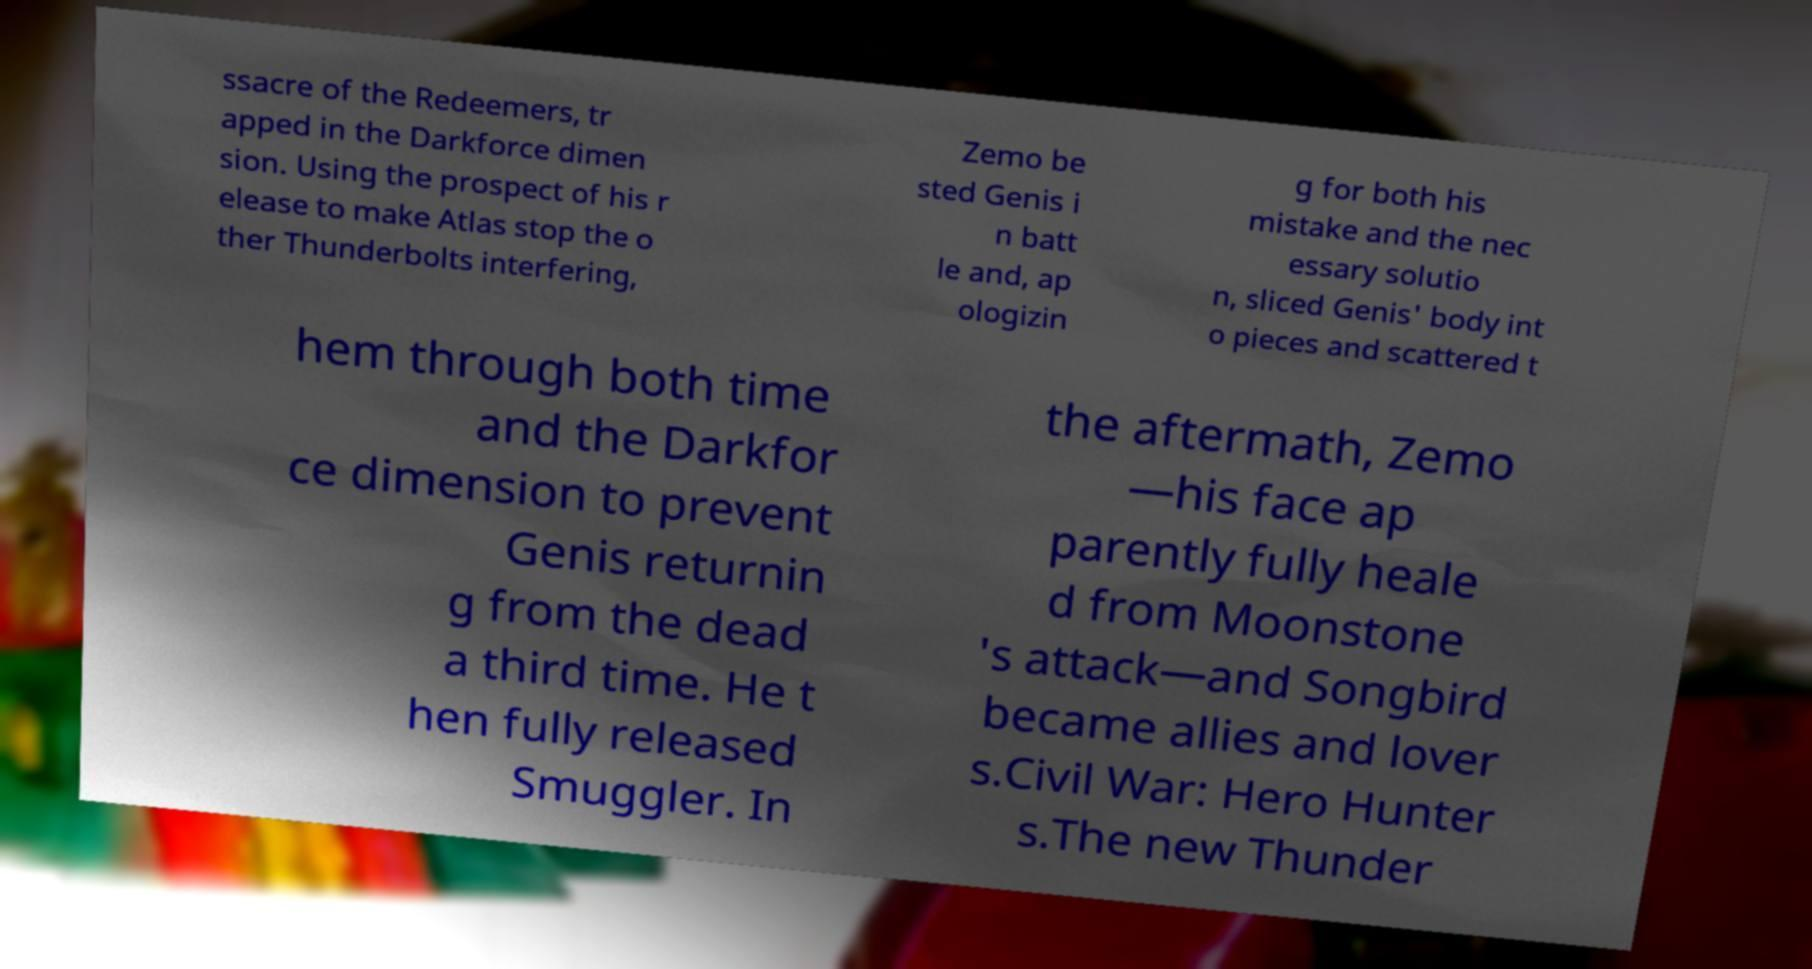Could you extract and type out the text from this image? ssacre of the Redeemers, tr apped in the Darkforce dimen sion. Using the prospect of his r elease to make Atlas stop the o ther Thunderbolts interfering, Zemo be sted Genis i n batt le and, ap ologizin g for both his mistake and the nec essary solutio n, sliced Genis' body int o pieces and scattered t hem through both time and the Darkfor ce dimension to prevent Genis returnin g from the dead a third time. He t hen fully released Smuggler. In the aftermath, Zemo —his face ap parently fully heale d from Moonstone 's attack—and Songbird became allies and lover s.Civil War: Hero Hunter s.The new Thunder 